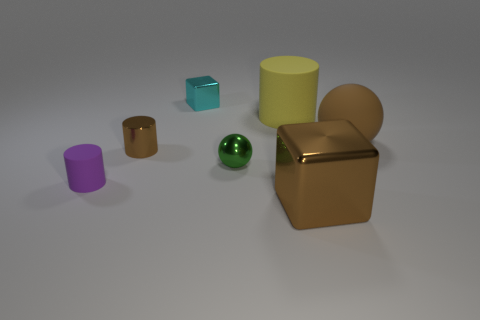Can you describe the shapes and colors of the objects? Certainly, there's a variety of geometric shapes: a green metallic sphere, a gold cube with a beveled edge, a purple cylinder, a blue transparent cube, and a yellow cylinder. Each object has a distinct, uniform color and smooth surface. 